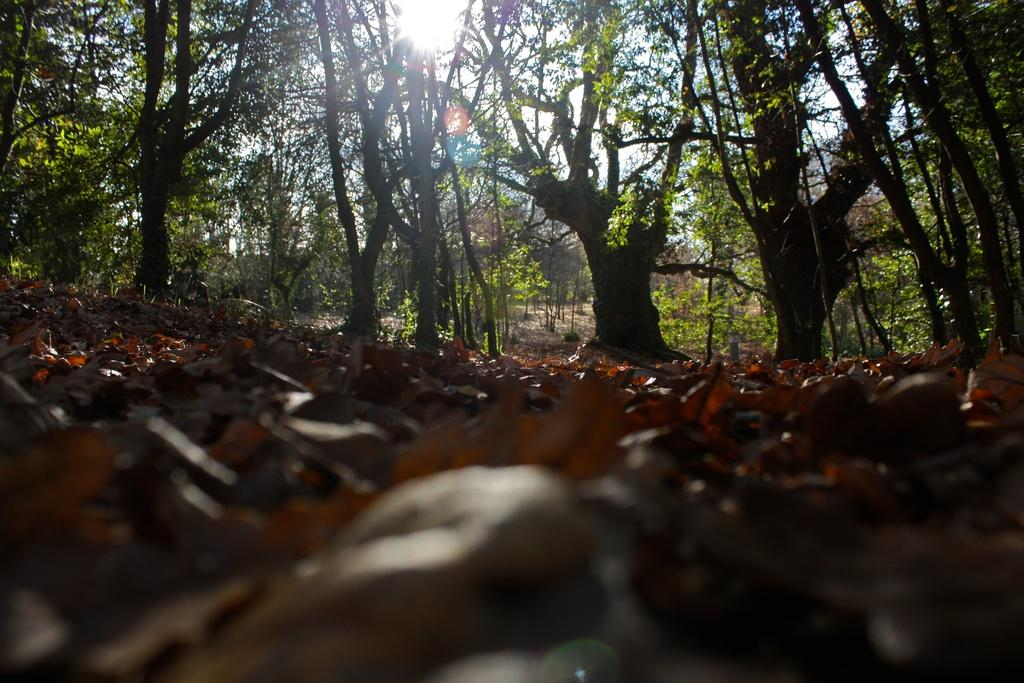What type of environment is shown in the image? The image depicts a forest. What are the main features of the forest? There are trees in the image. What can be seen in the sky in the image? The sky is visible at the top of the image, and the sun is present in the sky. What is visible at the bottom of the image? The ground is visible at the bottom of the image, and dried leaves are present on the ground. What type of trouble is the brother experiencing at the edge of the forest in the image? There is no brother or trouble depicted in the image; it only shows a forest with trees, the sky, the sun, the ground, and dried leaves. 